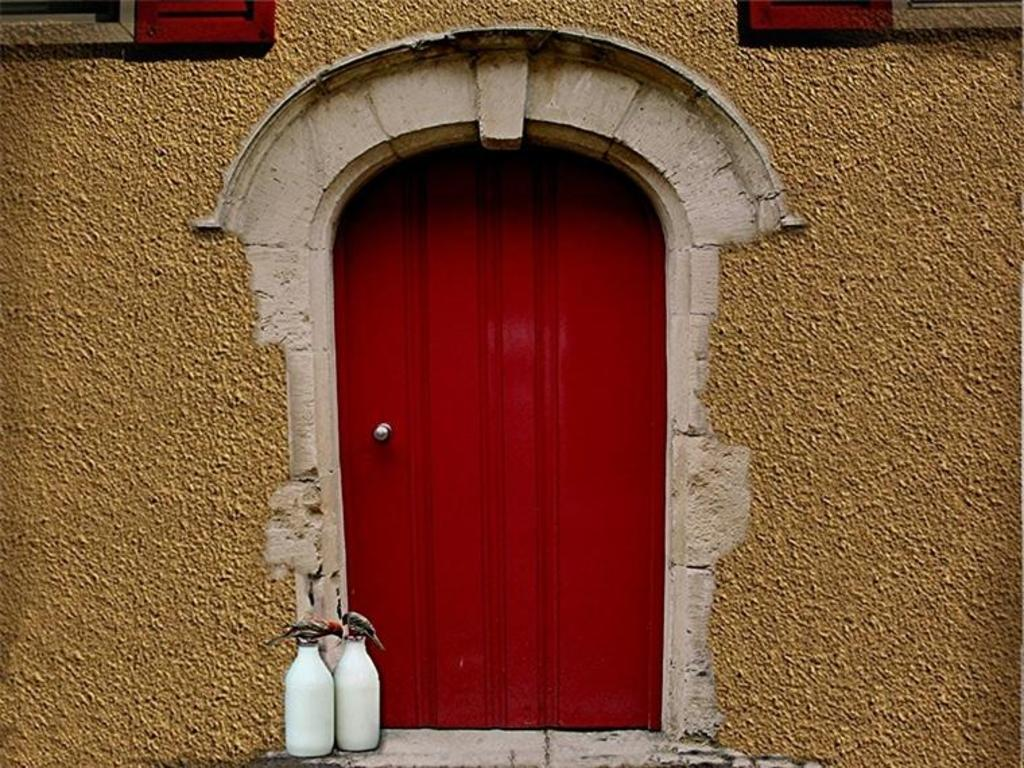What color is present in the image? The image contains red color. How many white bottles are in the image? There are two white bottles in the image. Where are the bottles placed? The bottles are placed on the floor. What is on top of the bottles? There are two birds on the bottles. What is the color of the wall in the image? There is a cream-colored wall in the image. What type of wool is being used by the birds in the image? There is no wool present in the image, and the birds are not using any wool. 